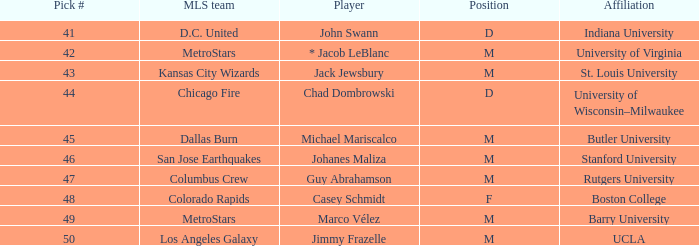What is the ucla pick with a number greater than 47? M. 